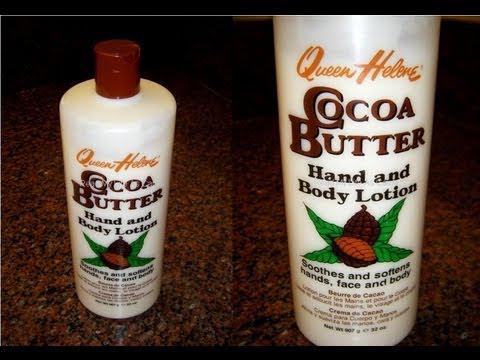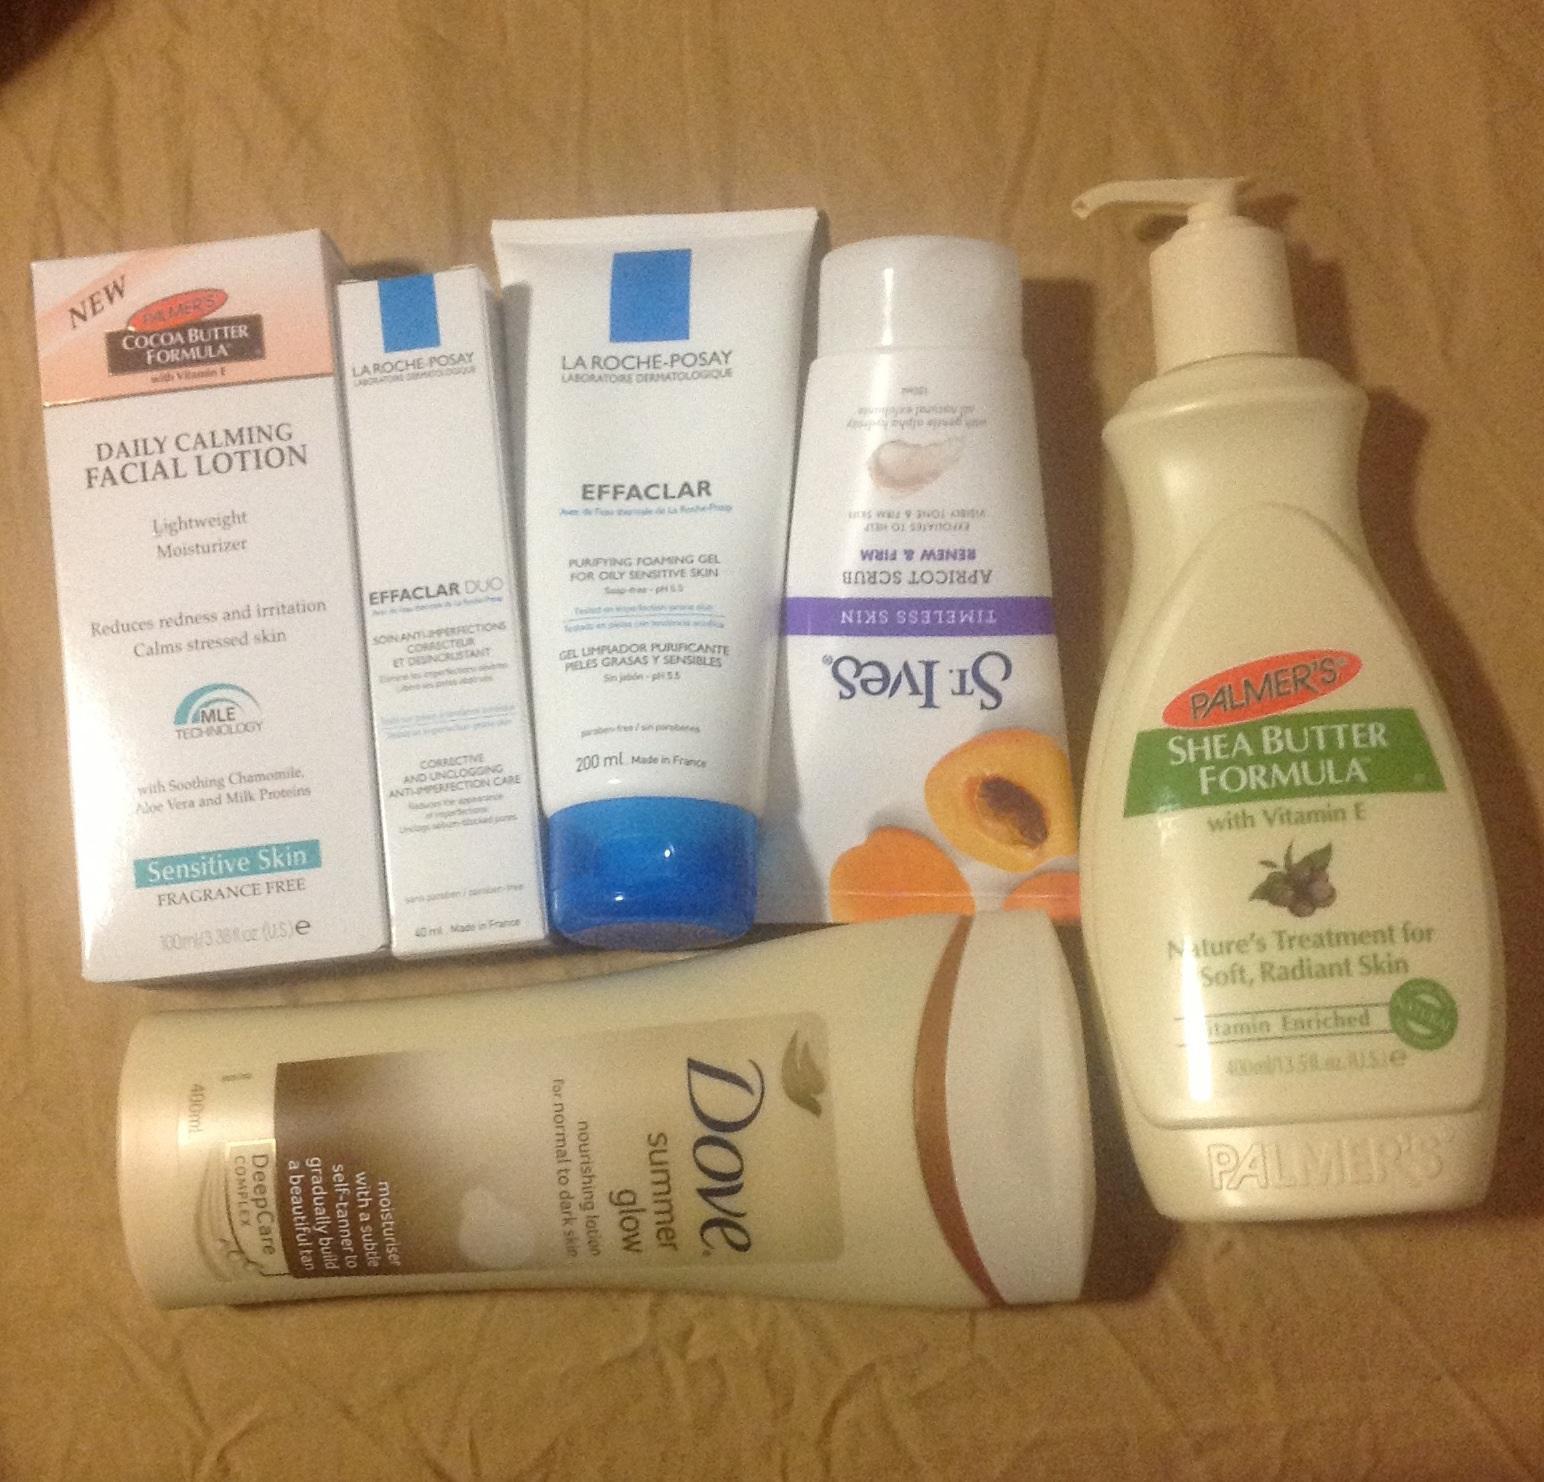The first image is the image on the left, the second image is the image on the right. Examine the images to the left and right. Is the description "Left image contains no more than 2 lotion products." accurate? Answer yes or no. Yes. 